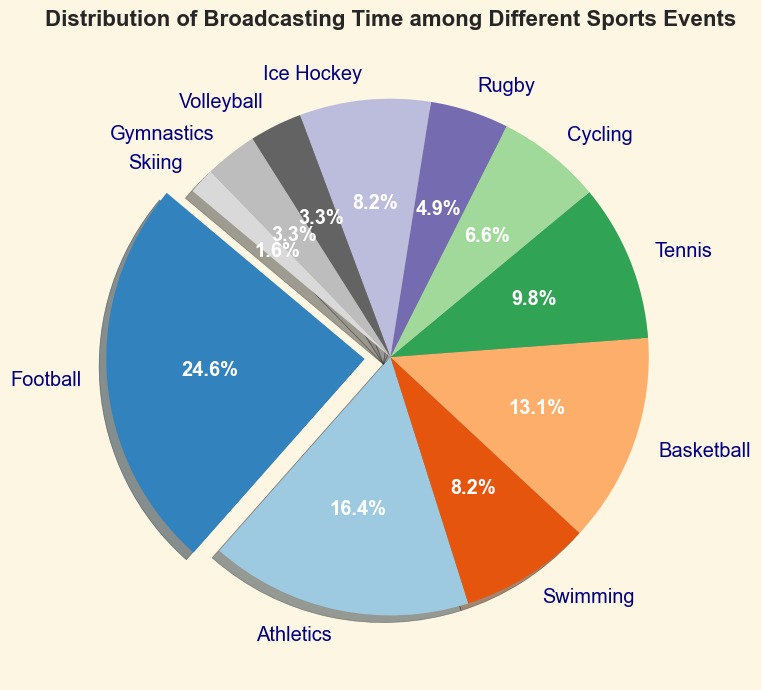What is the sport with the highest broadcasting time? The figure shows a pie chart of different sports with their corresponding broadcasting times. The largest slice in the chart represents the sport with the highest broadcasting time. This slice is also slightly separated from the rest.
Answer: Football Which sport has the smallest broadcasting time? The pie chart shows slices of varying sizes corresponding to the broadcasting times of different sports. The smallest slice in the pie chart represents the sport with 10 hours of broadcasting time.
Answer: Skiing By how much does the football broadcasting time exceed the combined broadcasting times of cycling and rugby? Football has 150 hours of broadcasting time. Cycling has 40 hours, and Rugby has 30 hours. So, combined, cycling and rugby have 40 + 30 = 70 hours. The excess is 150 - 70 = 80 hours.
Answer: 80 hours What percentage of the total broadcasting time is dedicated to tennis? The pie chart has percentages labeled on each slice, and the slice representing tennis is marked. By locating tennis on the chart, we see that it accounts for 12% of the total broadcasting time.
Answer: 12% Between basketball and ice hockey, which sport has more broadcasting time? The chart slices corresponding to basketball and ice hockey show times of 80 hours and 50 hours, respectively. Comparing these values, basketball has a larger slice.
Answer: Basketball How many sports have a broadcasting time of 50 hours or more? We need to identify slices labeled with 50 hours or more: Football (150 hours), Athletics (100 hours), Basketball (80 hours), Tennis (60 hours), Swimming (50 hours), Ice Hockey (50 hours). This totals 6 sports.
Answer: 6 sports What is the combined broadcasting time for gymnastics and volleyball? By examining the pie chart, we find the times for gymnastics (20 hours) and volleyball (20 hours). Adding these gives 20 + 20 = 40 hours.
Answer: 40 hours What is the average broadcasting time for all the sports listed? The total broadcasting time comes from adding the hours of all sports: 150 + 100 + 50 + 80 + 60 + 40 + 30 + 50 + 20 + 20 + 10 = 610 hours. With 11 sports, the average is 610 / 11 ≈ 55.45 hours.
Answer: 55.45 hours What is the total broadcasting time for events other than football and athletics? Excluding football (150 hours) and athletics (100 hours), sum the times of the other sports: 50 + 80 + 60 + 40 + 30 + 50 + 20 + 20 + 10 = 360 hours.
Answer: 360 hours Which sport broadcasting time is represented by a color near the end of the visible spectrum (reddish)? The pie chart uses a color gradient for different slices. The sport with a reddish slice is athletics.
Answer: Athletics 